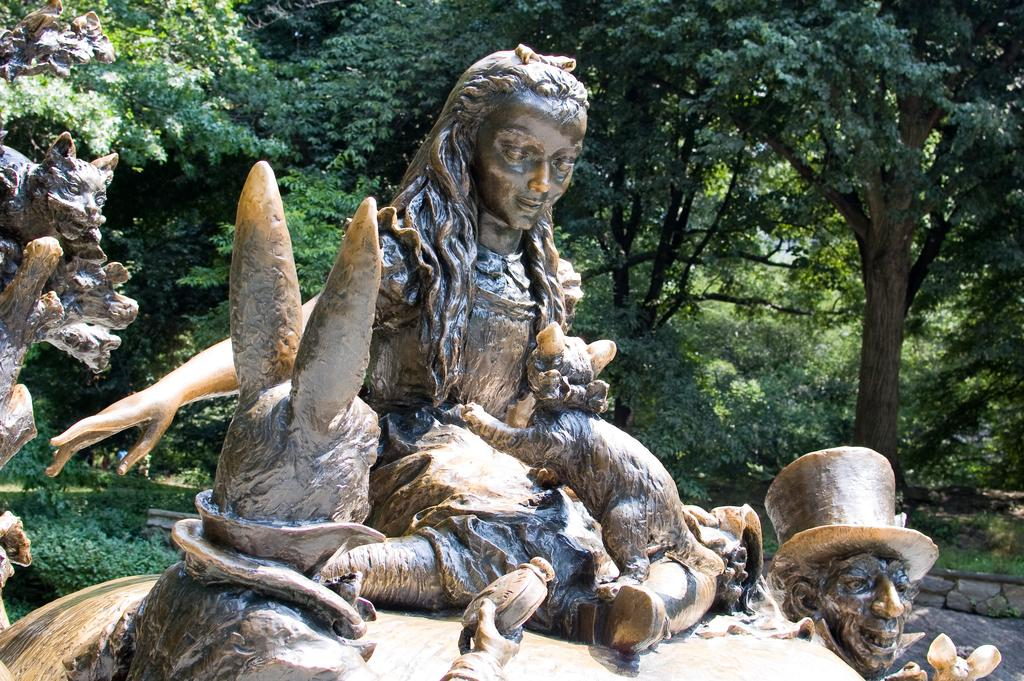What types of statues can be seen in the image? There are statues of persons and animals in the image. Where are the statues located? The statues are on a platform. What can be seen in the background of the image? There are trees and grass in the background of the image. What type of engine can be seen powering the statues in the image? There is no engine present in the image; the statues are stationary. What point is being made by the arrangement of the statues in the image? The image does not convey a specific point or message; it simply depicts statues on a platform with a background of trees and grass. 